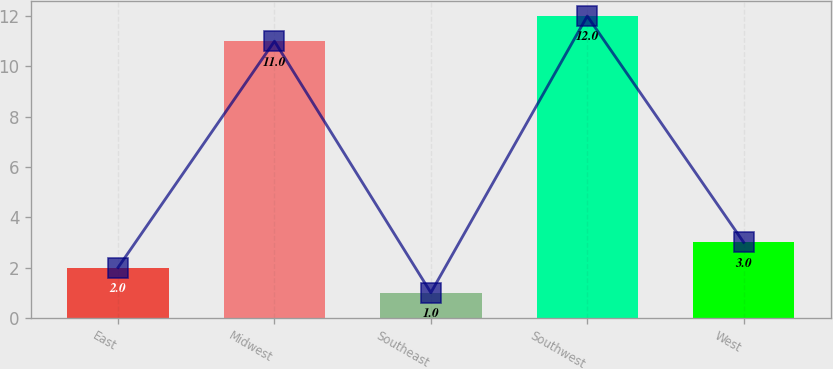<chart> <loc_0><loc_0><loc_500><loc_500><bar_chart><fcel>East<fcel>Midwest<fcel>Southeast<fcel>Southwest<fcel>West<nl><fcel>2<fcel>11<fcel>1<fcel>12<fcel>3<nl></chart> 